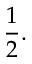<formula> <loc_0><loc_0><loc_500><loc_500>{ \frac { 1 } { 2 } } .</formula> 